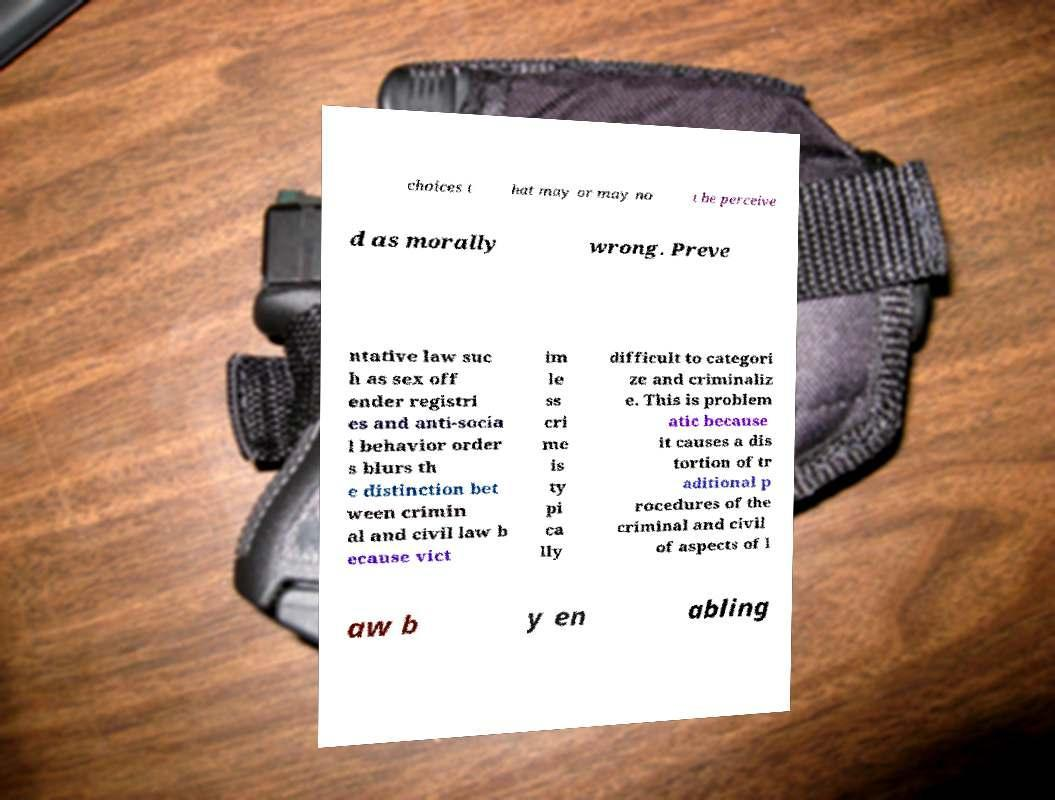For documentation purposes, I need the text within this image transcribed. Could you provide that? choices t hat may or may no t be perceive d as morally wrong. Preve ntative law suc h as sex off ender registri es and anti-socia l behavior order s blurs th e distinction bet ween crimin al and civil law b ecause vict im le ss cri me is ty pi ca lly difficult to categori ze and criminaliz e. This is problem atic because it causes a dis tortion of tr aditional p rocedures of the criminal and civil of aspects of l aw b y en abling 